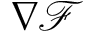<formula> <loc_0><loc_0><loc_500><loc_500>\nabla \mathcal { F }</formula> 